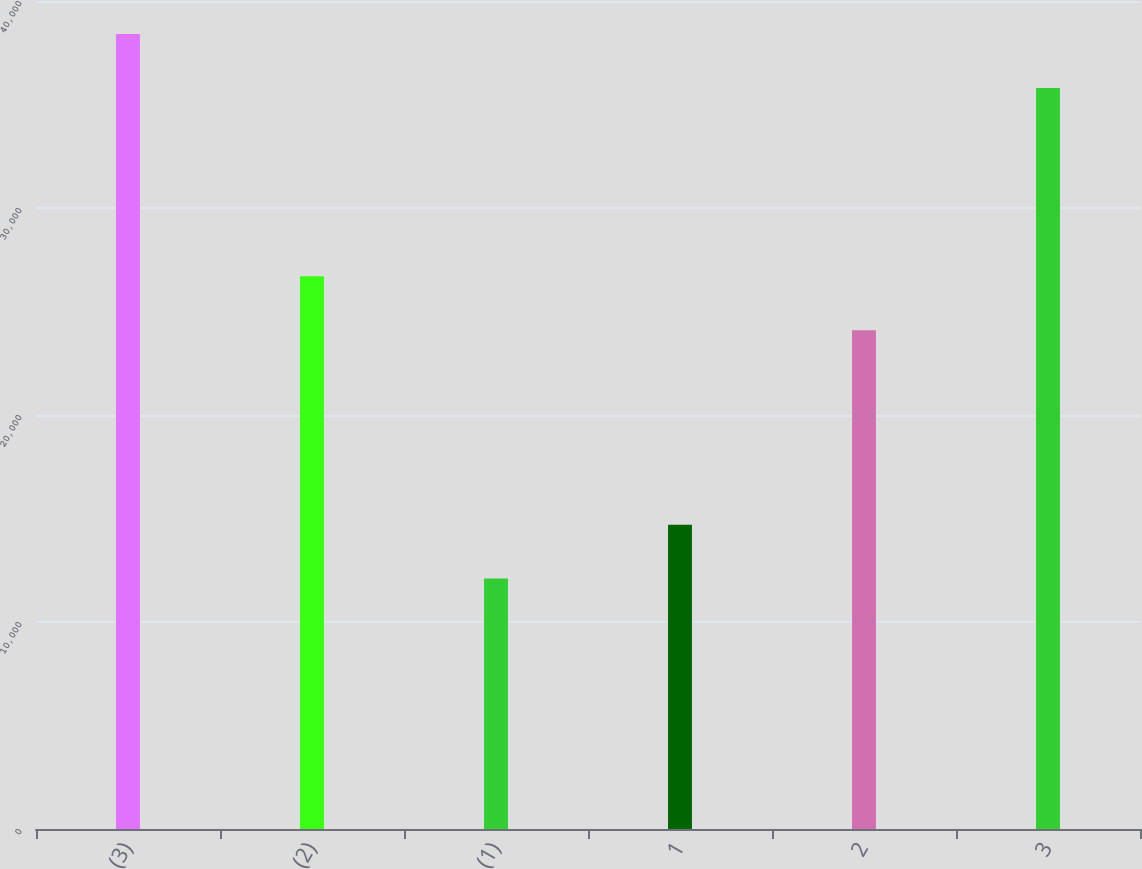Convert chart. <chart><loc_0><loc_0><loc_500><loc_500><bar_chart><fcel>(3)<fcel>(2)<fcel>(1)<fcel>1<fcel>2<fcel>3<nl><fcel>38400<fcel>26700<fcel>12100<fcel>14700<fcel>24100<fcel>35800<nl></chart> 